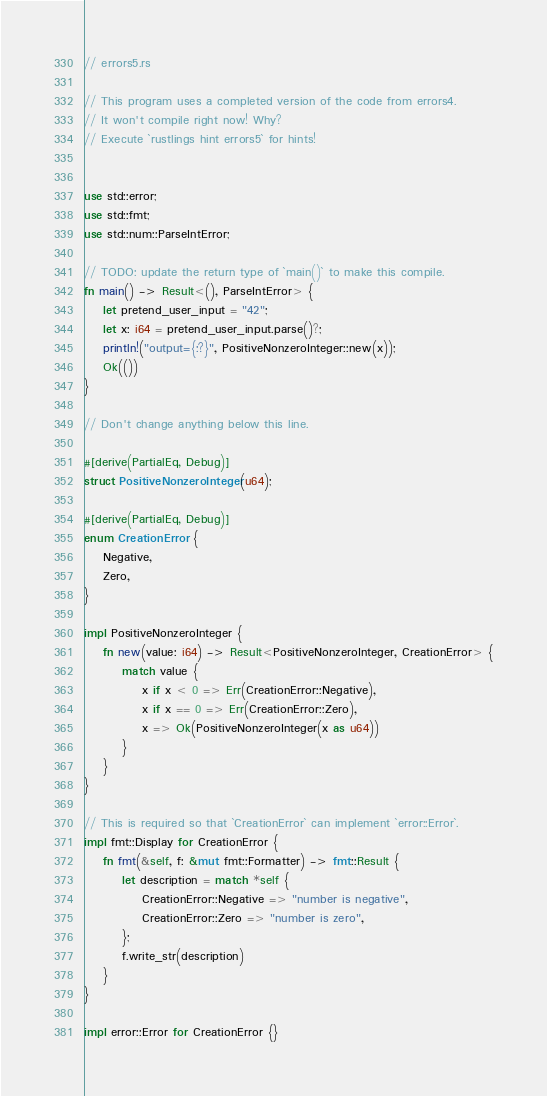Convert code to text. <code><loc_0><loc_0><loc_500><loc_500><_Rust_>// errors5.rs

// This program uses a completed version of the code from errors4.
// It won't compile right now! Why?
// Execute `rustlings hint errors5` for hints!


use std::error;
use std::fmt;
use std::num::ParseIntError;

// TODO: update the return type of `main()` to make this compile.
fn main() -> Result<(), ParseIntError> {
    let pretend_user_input = "42";
    let x: i64 = pretend_user_input.parse()?;
    println!("output={:?}", PositiveNonzeroInteger::new(x));
    Ok(())
}

// Don't change anything below this line.

#[derive(PartialEq, Debug)]
struct PositiveNonzeroInteger(u64);

#[derive(PartialEq, Debug)]
enum CreationError {
    Negative,
    Zero,
}

impl PositiveNonzeroInteger {
    fn new(value: i64) -> Result<PositiveNonzeroInteger, CreationError> {
        match value {
            x if x < 0 => Err(CreationError::Negative),
            x if x == 0 => Err(CreationError::Zero),
            x => Ok(PositiveNonzeroInteger(x as u64))
        }
    }
}

// This is required so that `CreationError` can implement `error::Error`.
impl fmt::Display for CreationError {
    fn fmt(&self, f: &mut fmt::Formatter) -> fmt::Result {
        let description = match *self {
            CreationError::Negative => "number is negative",
            CreationError::Zero => "number is zero",
        };
        f.write_str(description)
    }
}

impl error::Error for CreationError {}


</code> 